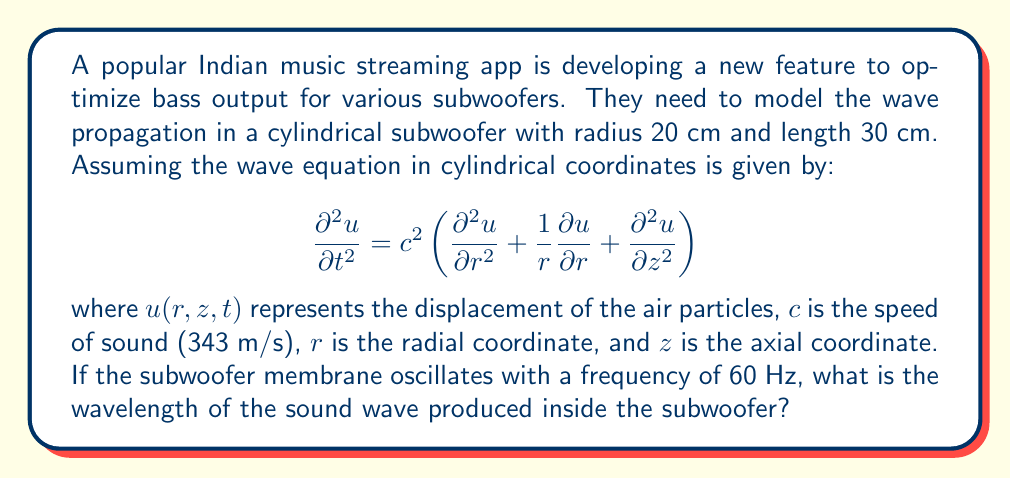Can you solve this math problem? To solve this problem, we need to use the relationship between frequency, wavelength, and wave speed. Let's break it down step by step:

1. We're given the following information:
   - Frequency, $f = 60$ Hz
   - Speed of sound, $c = 343$ m/s

2. The general relationship between frequency ($f$), wavelength ($\lambda$), and wave speed ($c$) is:

   $$ c = f\lambda $$

3. We can rearrange this equation to solve for the wavelength:

   $$ \lambda = \frac{c}{f} $$

4. Now, let's substitute our known values:

   $$ \lambda = \frac{343 \text{ m/s}}{60 \text{ Hz}} $$

5. Simplify:

   $$ \lambda = \frac{343}{60} \text{ m} $$

6. Calculate the final result:

   $$ \lambda \approx 5.72 \text{ m} $$

It's worth noting that this wavelength (5.72 m) is much larger than the dimensions of the subwoofer (0.3 m length). This is typical for low-frequency sounds and explains why bass sounds can easily pass through walls and obstacles.
Answer: The wavelength of the sound wave produced inside the subwoofer is approximately 5.72 meters. 